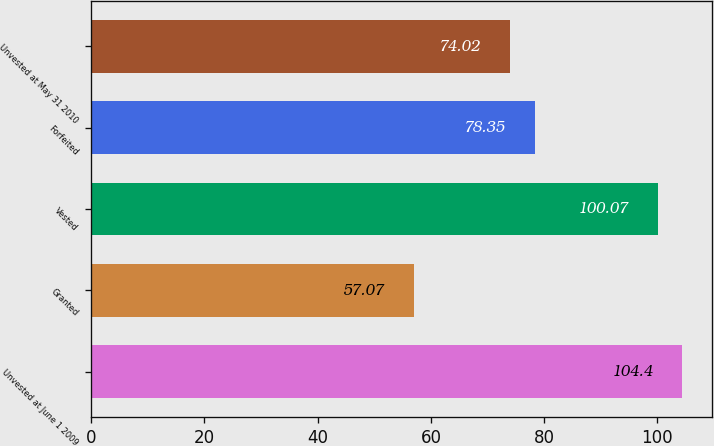<chart> <loc_0><loc_0><loc_500><loc_500><bar_chart><fcel>Unvested at June 1 2009<fcel>Granted<fcel>Vested<fcel>Forfeited<fcel>Unvested at May 31 2010<nl><fcel>104.4<fcel>57.07<fcel>100.07<fcel>78.35<fcel>74.02<nl></chart> 